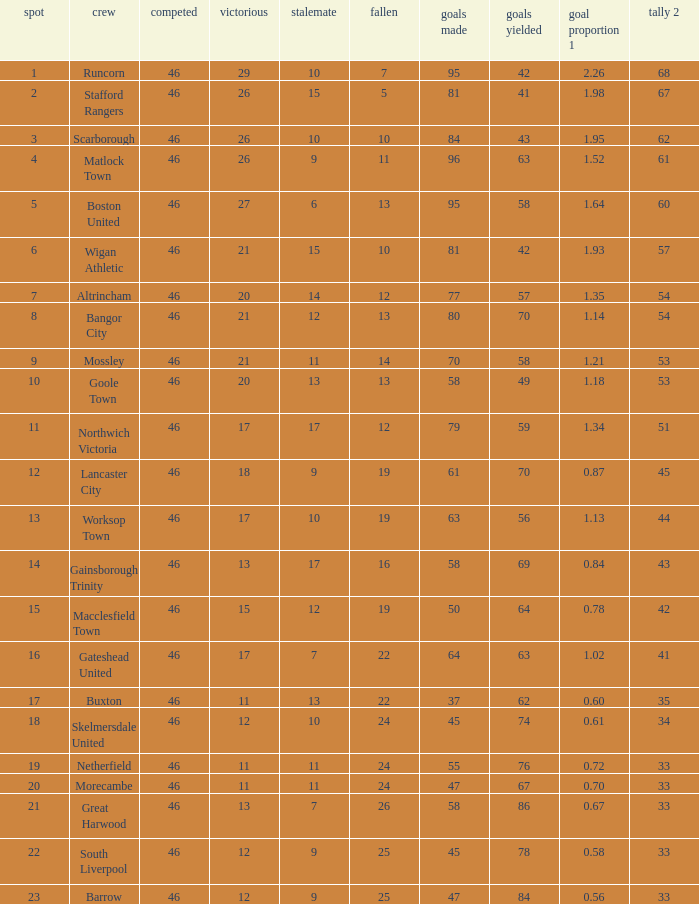Which team had goal averages of 1.34? Northwich Victoria. 